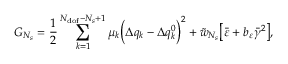Convert formula to latex. <formula><loc_0><loc_0><loc_500><loc_500>G _ { N _ { s } } = \frac { 1 } { 2 } \sum _ { k = 1 } ^ { N _ { d o f } - N _ { s } + 1 } { \mu _ { k } \left ( \Delta q _ { k } - \Delta q _ { k } ^ { 0 } \right ) ^ { 2 } } + \tilde { w } _ { N _ { s } } \left [ \bar { \varepsilon } + b _ { \varepsilon } \bar { \gamma } ^ { 2 } \right ] ,</formula> 